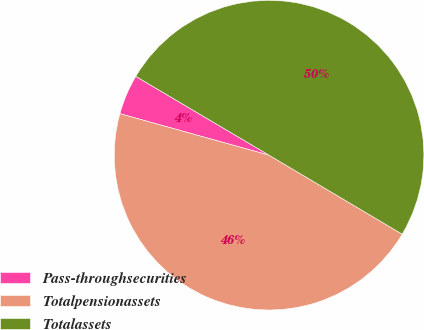Convert chart to OTSL. <chart><loc_0><loc_0><loc_500><loc_500><pie_chart><fcel>Pass-throughsecurities<fcel>Totalpensionassets<fcel>Totalassets<nl><fcel>4.18%<fcel>45.8%<fcel>50.02%<nl></chart> 